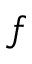Convert formula to latex. <formula><loc_0><loc_0><loc_500><loc_500>f</formula> 